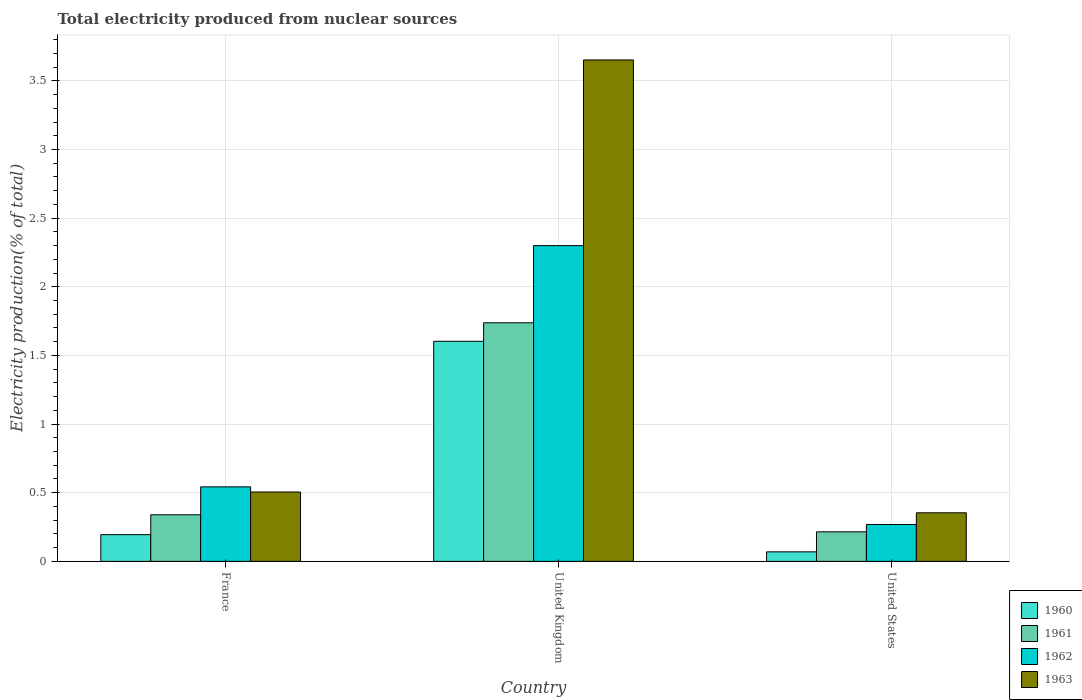How many groups of bars are there?
Offer a very short reply. 3. Are the number of bars per tick equal to the number of legend labels?
Your answer should be very brief. Yes. Are the number of bars on each tick of the X-axis equal?
Your answer should be compact. Yes. How many bars are there on the 3rd tick from the left?
Your answer should be compact. 4. How many bars are there on the 3rd tick from the right?
Your answer should be compact. 4. In how many cases, is the number of bars for a given country not equal to the number of legend labels?
Provide a succinct answer. 0. What is the total electricity produced in 1962 in France?
Your response must be concise. 0.54. Across all countries, what is the maximum total electricity produced in 1961?
Make the answer very short. 1.74. Across all countries, what is the minimum total electricity produced in 1961?
Ensure brevity in your answer.  0.22. In which country was the total electricity produced in 1960 maximum?
Ensure brevity in your answer.  United Kingdom. What is the total total electricity produced in 1961 in the graph?
Give a very brief answer. 2.29. What is the difference between the total electricity produced in 1963 in United Kingdom and that in United States?
Provide a short and direct response. 3.3. What is the difference between the total electricity produced in 1962 in United Kingdom and the total electricity produced in 1961 in France?
Offer a very short reply. 1.96. What is the average total electricity produced in 1960 per country?
Make the answer very short. 0.62. What is the difference between the total electricity produced of/in 1963 and total electricity produced of/in 1960 in France?
Your answer should be compact. 0.31. What is the ratio of the total electricity produced in 1961 in France to that in United States?
Your answer should be very brief. 1.58. Is the total electricity produced in 1963 in France less than that in United Kingdom?
Provide a succinct answer. Yes. What is the difference between the highest and the second highest total electricity produced in 1960?
Provide a short and direct response. -1.41. What is the difference between the highest and the lowest total electricity produced in 1961?
Keep it short and to the point. 1.52. In how many countries, is the total electricity produced in 1960 greater than the average total electricity produced in 1960 taken over all countries?
Offer a terse response. 1. Is the sum of the total electricity produced in 1962 in France and United Kingdom greater than the maximum total electricity produced in 1960 across all countries?
Your answer should be compact. Yes. What does the 4th bar from the left in United States represents?
Your answer should be very brief. 1963. Is it the case that in every country, the sum of the total electricity produced in 1963 and total electricity produced in 1962 is greater than the total electricity produced in 1961?
Provide a short and direct response. Yes. How many bars are there?
Offer a terse response. 12. How many countries are there in the graph?
Offer a very short reply. 3. Are the values on the major ticks of Y-axis written in scientific E-notation?
Give a very brief answer. No. How are the legend labels stacked?
Keep it short and to the point. Vertical. What is the title of the graph?
Provide a short and direct response. Total electricity produced from nuclear sources. What is the Electricity production(% of total) of 1960 in France?
Ensure brevity in your answer.  0.19. What is the Electricity production(% of total) of 1961 in France?
Keep it short and to the point. 0.34. What is the Electricity production(% of total) in 1962 in France?
Give a very brief answer. 0.54. What is the Electricity production(% of total) in 1963 in France?
Provide a short and direct response. 0.51. What is the Electricity production(% of total) of 1960 in United Kingdom?
Provide a short and direct response. 1.6. What is the Electricity production(% of total) of 1961 in United Kingdom?
Provide a succinct answer. 1.74. What is the Electricity production(% of total) of 1962 in United Kingdom?
Offer a very short reply. 2.3. What is the Electricity production(% of total) in 1963 in United Kingdom?
Your answer should be very brief. 3.65. What is the Electricity production(% of total) in 1960 in United States?
Make the answer very short. 0.07. What is the Electricity production(% of total) in 1961 in United States?
Your answer should be very brief. 0.22. What is the Electricity production(% of total) in 1962 in United States?
Provide a succinct answer. 0.27. What is the Electricity production(% of total) of 1963 in United States?
Your answer should be very brief. 0.35. Across all countries, what is the maximum Electricity production(% of total) of 1960?
Offer a terse response. 1.6. Across all countries, what is the maximum Electricity production(% of total) in 1961?
Your response must be concise. 1.74. Across all countries, what is the maximum Electricity production(% of total) in 1962?
Offer a terse response. 2.3. Across all countries, what is the maximum Electricity production(% of total) in 1963?
Keep it short and to the point. 3.65. Across all countries, what is the minimum Electricity production(% of total) in 1960?
Your answer should be very brief. 0.07. Across all countries, what is the minimum Electricity production(% of total) in 1961?
Offer a very short reply. 0.22. Across all countries, what is the minimum Electricity production(% of total) in 1962?
Your answer should be very brief. 0.27. Across all countries, what is the minimum Electricity production(% of total) in 1963?
Give a very brief answer. 0.35. What is the total Electricity production(% of total) in 1960 in the graph?
Keep it short and to the point. 1.87. What is the total Electricity production(% of total) in 1961 in the graph?
Keep it short and to the point. 2.29. What is the total Electricity production(% of total) of 1962 in the graph?
Make the answer very short. 3.11. What is the total Electricity production(% of total) of 1963 in the graph?
Your response must be concise. 4.51. What is the difference between the Electricity production(% of total) of 1960 in France and that in United Kingdom?
Ensure brevity in your answer.  -1.41. What is the difference between the Electricity production(% of total) in 1961 in France and that in United Kingdom?
Keep it short and to the point. -1.4. What is the difference between the Electricity production(% of total) of 1962 in France and that in United Kingdom?
Your response must be concise. -1.76. What is the difference between the Electricity production(% of total) in 1963 in France and that in United Kingdom?
Your response must be concise. -3.15. What is the difference between the Electricity production(% of total) in 1960 in France and that in United States?
Provide a short and direct response. 0.13. What is the difference between the Electricity production(% of total) of 1961 in France and that in United States?
Keep it short and to the point. 0.12. What is the difference between the Electricity production(% of total) of 1962 in France and that in United States?
Keep it short and to the point. 0.27. What is the difference between the Electricity production(% of total) of 1963 in France and that in United States?
Give a very brief answer. 0.15. What is the difference between the Electricity production(% of total) in 1960 in United Kingdom and that in United States?
Provide a succinct answer. 1.53. What is the difference between the Electricity production(% of total) in 1961 in United Kingdom and that in United States?
Provide a succinct answer. 1.52. What is the difference between the Electricity production(% of total) of 1962 in United Kingdom and that in United States?
Provide a short and direct response. 2.03. What is the difference between the Electricity production(% of total) in 1963 in United Kingdom and that in United States?
Give a very brief answer. 3.3. What is the difference between the Electricity production(% of total) of 1960 in France and the Electricity production(% of total) of 1961 in United Kingdom?
Provide a short and direct response. -1.54. What is the difference between the Electricity production(% of total) of 1960 in France and the Electricity production(% of total) of 1962 in United Kingdom?
Provide a succinct answer. -2.11. What is the difference between the Electricity production(% of total) of 1960 in France and the Electricity production(% of total) of 1963 in United Kingdom?
Provide a short and direct response. -3.46. What is the difference between the Electricity production(% of total) in 1961 in France and the Electricity production(% of total) in 1962 in United Kingdom?
Keep it short and to the point. -1.96. What is the difference between the Electricity production(% of total) in 1961 in France and the Electricity production(% of total) in 1963 in United Kingdom?
Your answer should be compact. -3.31. What is the difference between the Electricity production(% of total) of 1962 in France and the Electricity production(% of total) of 1963 in United Kingdom?
Keep it short and to the point. -3.11. What is the difference between the Electricity production(% of total) in 1960 in France and the Electricity production(% of total) in 1961 in United States?
Your answer should be compact. -0.02. What is the difference between the Electricity production(% of total) of 1960 in France and the Electricity production(% of total) of 1962 in United States?
Give a very brief answer. -0.07. What is the difference between the Electricity production(% of total) in 1960 in France and the Electricity production(% of total) in 1963 in United States?
Your answer should be compact. -0.16. What is the difference between the Electricity production(% of total) in 1961 in France and the Electricity production(% of total) in 1962 in United States?
Your answer should be very brief. 0.07. What is the difference between the Electricity production(% of total) of 1961 in France and the Electricity production(% of total) of 1963 in United States?
Your answer should be compact. -0.01. What is the difference between the Electricity production(% of total) of 1962 in France and the Electricity production(% of total) of 1963 in United States?
Your response must be concise. 0.19. What is the difference between the Electricity production(% of total) in 1960 in United Kingdom and the Electricity production(% of total) in 1961 in United States?
Provide a short and direct response. 1.39. What is the difference between the Electricity production(% of total) in 1960 in United Kingdom and the Electricity production(% of total) in 1962 in United States?
Offer a terse response. 1.33. What is the difference between the Electricity production(% of total) in 1960 in United Kingdom and the Electricity production(% of total) in 1963 in United States?
Give a very brief answer. 1.25. What is the difference between the Electricity production(% of total) of 1961 in United Kingdom and the Electricity production(% of total) of 1962 in United States?
Provide a short and direct response. 1.47. What is the difference between the Electricity production(% of total) in 1961 in United Kingdom and the Electricity production(% of total) in 1963 in United States?
Offer a terse response. 1.38. What is the difference between the Electricity production(% of total) in 1962 in United Kingdom and the Electricity production(% of total) in 1963 in United States?
Give a very brief answer. 1.95. What is the average Electricity production(% of total) of 1960 per country?
Ensure brevity in your answer.  0.62. What is the average Electricity production(% of total) in 1961 per country?
Give a very brief answer. 0.76. What is the average Electricity production(% of total) of 1962 per country?
Keep it short and to the point. 1.04. What is the average Electricity production(% of total) in 1963 per country?
Make the answer very short. 1.5. What is the difference between the Electricity production(% of total) in 1960 and Electricity production(% of total) in 1961 in France?
Make the answer very short. -0.14. What is the difference between the Electricity production(% of total) in 1960 and Electricity production(% of total) in 1962 in France?
Offer a very short reply. -0.35. What is the difference between the Electricity production(% of total) in 1960 and Electricity production(% of total) in 1963 in France?
Keep it short and to the point. -0.31. What is the difference between the Electricity production(% of total) of 1961 and Electricity production(% of total) of 1962 in France?
Give a very brief answer. -0.2. What is the difference between the Electricity production(% of total) in 1961 and Electricity production(% of total) in 1963 in France?
Make the answer very short. -0.17. What is the difference between the Electricity production(% of total) of 1962 and Electricity production(% of total) of 1963 in France?
Offer a terse response. 0.04. What is the difference between the Electricity production(% of total) of 1960 and Electricity production(% of total) of 1961 in United Kingdom?
Your answer should be compact. -0.13. What is the difference between the Electricity production(% of total) in 1960 and Electricity production(% of total) in 1962 in United Kingdom?
Your response must be concise. -0.7. What is the difference between the Electricity production(% of total) in 1960 and Electricity production(% of total) in 1963 in United Kingdom?
Give a very brief answer. -2.05. What is the difference between the Electricity production(% of total) in 1961 and Electricity production(% of total) in 1962 in United Kingdom?
Offer a terse response. -0.56. What is the difference between the Electricity production(% of total) of 1961 and Electricity production(% of total) of 1963 in United Kingdom?
Offer a very short reply. -1.91. What is the difference between the Electricity production(% of total) in 1962 and Electricity production(% of total) in 1963 in United Kingdom?
Provide a succinct answer. -1.35. What is the difference between the Electricity production(% of total) of 1960 and Electricity production(% of total) of 1961 in United States?
Give a very brief answer. -0.15. What is the difference between the Electricity production(% of total) in 1960 and Electricity production(% of total) in 1962 in United States?
Provide a succinct answer. -0.2. What is the difference between the Electricity production(% of total) in 1960 and Electricity production(% of total) in 1963 in United States?
Your response must be concise. -0.28. What is the difference between the Electricity production(% of total) in 1961 and Electricity production(% of total) in 1962 in United States?
Your answer should be very brief. -0.05. What is the difference between the Electricity production(% of total) in 1961 and Electricity production(% of total) in 1963 in United States?
Ensure brevity in your answer.  -0.14. What is the difference between the Electricity production(% of total) of 1962 and Electricity production(% of total) of 1963 in United States?
Make the answer very short. -0.09. What is the ratio of the Electricity production(% of total) in 1960 in France to that in United Kingdom?
Provide a succinct answer. 0.12. What is the ratio of the Electricity production(% of total) in 1961 in France to that in United Kingdom?
Make the answer very short. 0.2. What is the ratio of the Electricity production(% of total) in 1962 in France to that in United Kingdom?
Keep it short and to the point. 0.24. What is the ratio of the Electricity production(% of total) in 1963 in France to that in United Kingdom?
Make the answer very short. 0.14. What is the ratio of the Electricity production(% of total) of 1960 in France to that in United States?
Provide a succinct answer. 2.81. What is the ratio of the Electricity production(% of total) of 1961 in France to that in United States?
Keep it short and to the point. 1.58. What is the ratio of the Electricity production(% of total) of 1962 in France to that in United States?
Offer a terse response. 2.02. What is the ratio of the Electricity production(% of total) of 1963 in France to that in United States?
Make the answer very short. 1.43. What is the ratio of the Electricity production(% of total) of 1960 in United Kingdom to that in United States?
Your answer should be very brief. 23.14. What is the ratio of the Electricity production(% of total) in 1961 in United Kingdom to that in United States?
Your answer should be compact. 8.08. What is the ratio of the Electricity production(% of total) of 1962 in United Kingdom to that in United States?
Make the answer very short. 8.56. What is the ratio of the Electricity production(% of total) in 1963 in United Kingdom to that in United States?
Offer a terse response. 10.32. What is the difference between the highest and the second highest Electricity production(% of total) of 1960?
Your answer should be very brief. 1.41. What is the difference between the highest and the second highest Electricity production(% of total) of 1961?
Your answer should be compact. 1.4. What is the difference between the highest and the second highest Electricity production(% of total) of 1962?
Make the answer very short. 1.76. What is the difference between the highest and the second highest Electricity production(% of total) in 1963?
Provide a succinct answer. 3.15. What is the difference between the highest and the lowest Electricity production(% of total) of 1960?
Your answer should be compact. 1.53. What is the difference between the highest and the lowest Electricity production(% of total) in 1961?
Make the answer very short. 1.52. What is the difference between the highest and the lowest Electricity production(% of total) of 1962?
Your answer should be compact. 2.03. What is the difference between the highest and the lowest Electricity production(% of total) in 1963?
Your response must be concise. 3.3. 